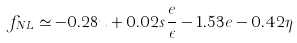Convert formula to latex. <formula><loc_0><loc_0><loc_500><loc_500>f _ { N L } \simeq - 0 . 2 8 u + 0 . 0 2 s \frac { e } { \epsilon } - 1 . 5 3 e - 0 . 4 2 \eta</formula> 